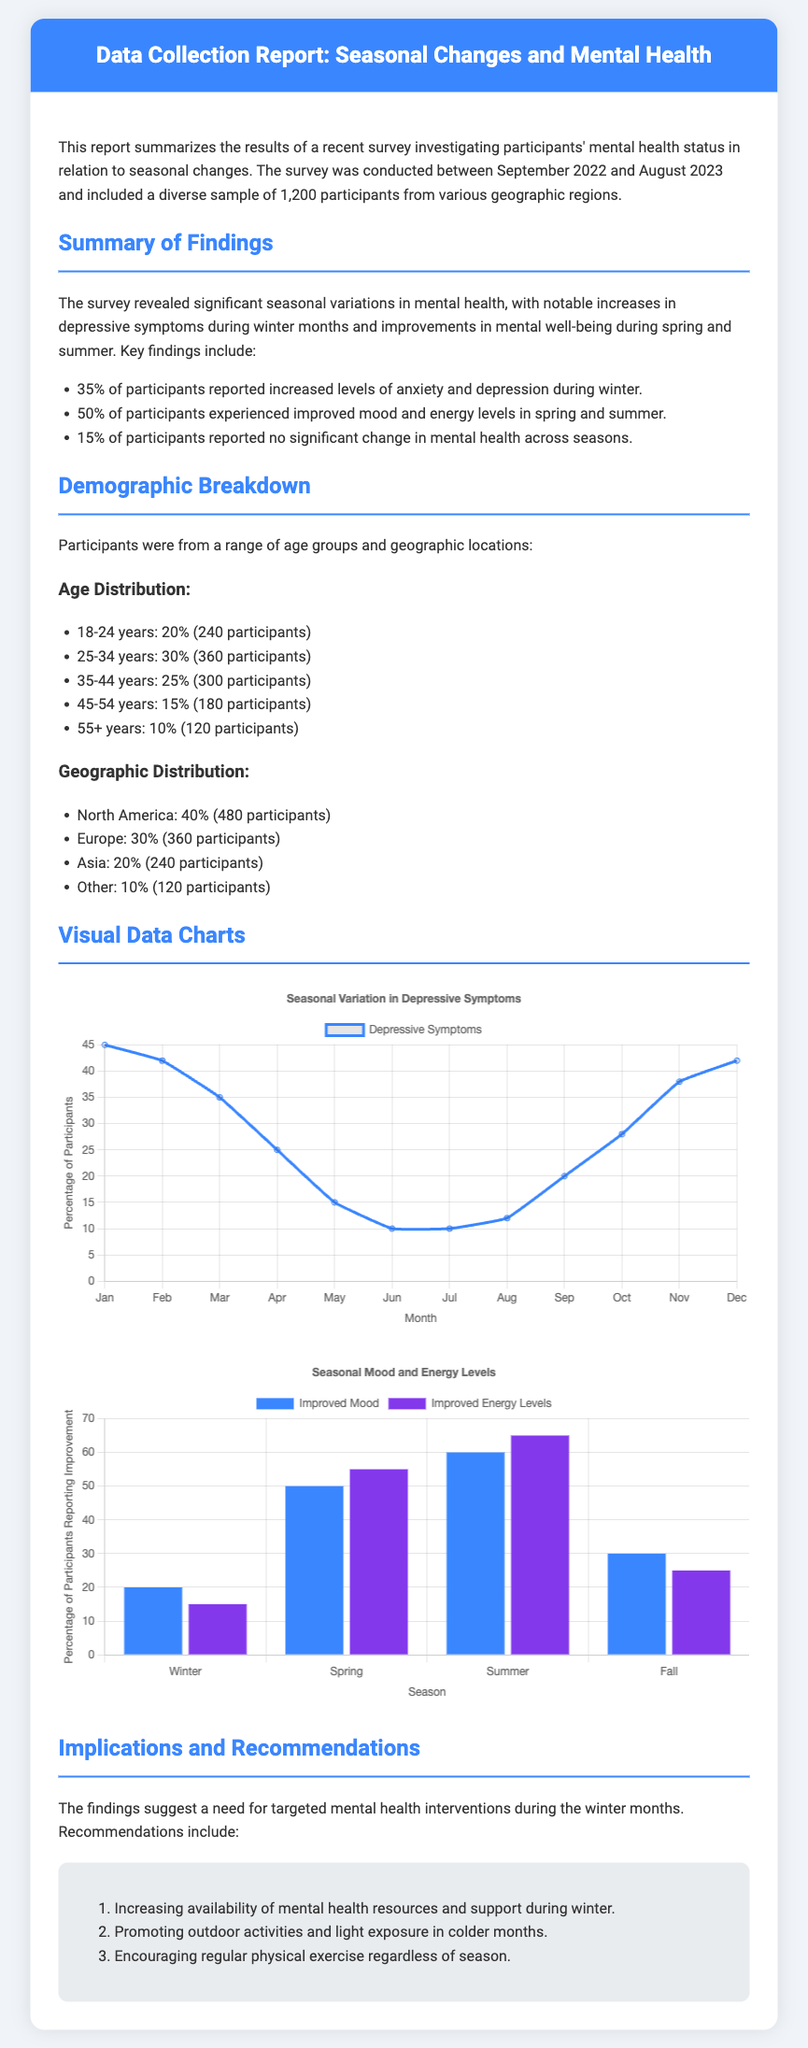What percentage of participants reported increased anxiety and depression during winter? The document states that 35% of participants reported increased levels of anxiety and depression during winter.
Answer: 35% How many participants were surveyed in total? The document mentions that a diverse sample of 1,200 participants was included in the survey.
Answer: 1,200 What percentage of participants reported improved mood in spring and summer? The report indicates that 50% of participants experienced improved mood and energy levels in spring and summer.
Answer: 50% How many participants aged 25-34 were in the study? According to the demographic breakdown, there were 360 participants aged 25-34 years.
Answer: 360 What is the highest percentage of participants reporting improved energy levels and during which season? The data shows that 65% of participants reported improved energy levels during summer.
Answer: 65% (summer) What is the title of the report? The document header states that the title of the report is "Data Collection Report: Seasonal Changes and Mental Health".
Answer: Data Collection Report: Seasonal Changes and Mental Health What was the percentage of participants aged 55 and older? The age distribution indicates that 10% of participants were aged 55 or older.
Answer: 10% What is the suggested intervention during the winter months? The recommendations section suggests increasing the availability of mental health resources and support during winter.
Answer: Increasing availability of mental health resources What chart type is used to display seasonal variation in depressive symptoms? The document mentions that a line chart is used for displaying seasonal variation in depressive symptoms.
Answer: Line chart 